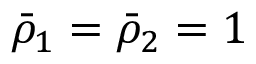Convert formula to latex. <formula><loc_0><loc_0><loc_500><loc_500>\bar { \rho } _ { 1 } = \bar { \rho } _ { 2 } = 1</formula> 